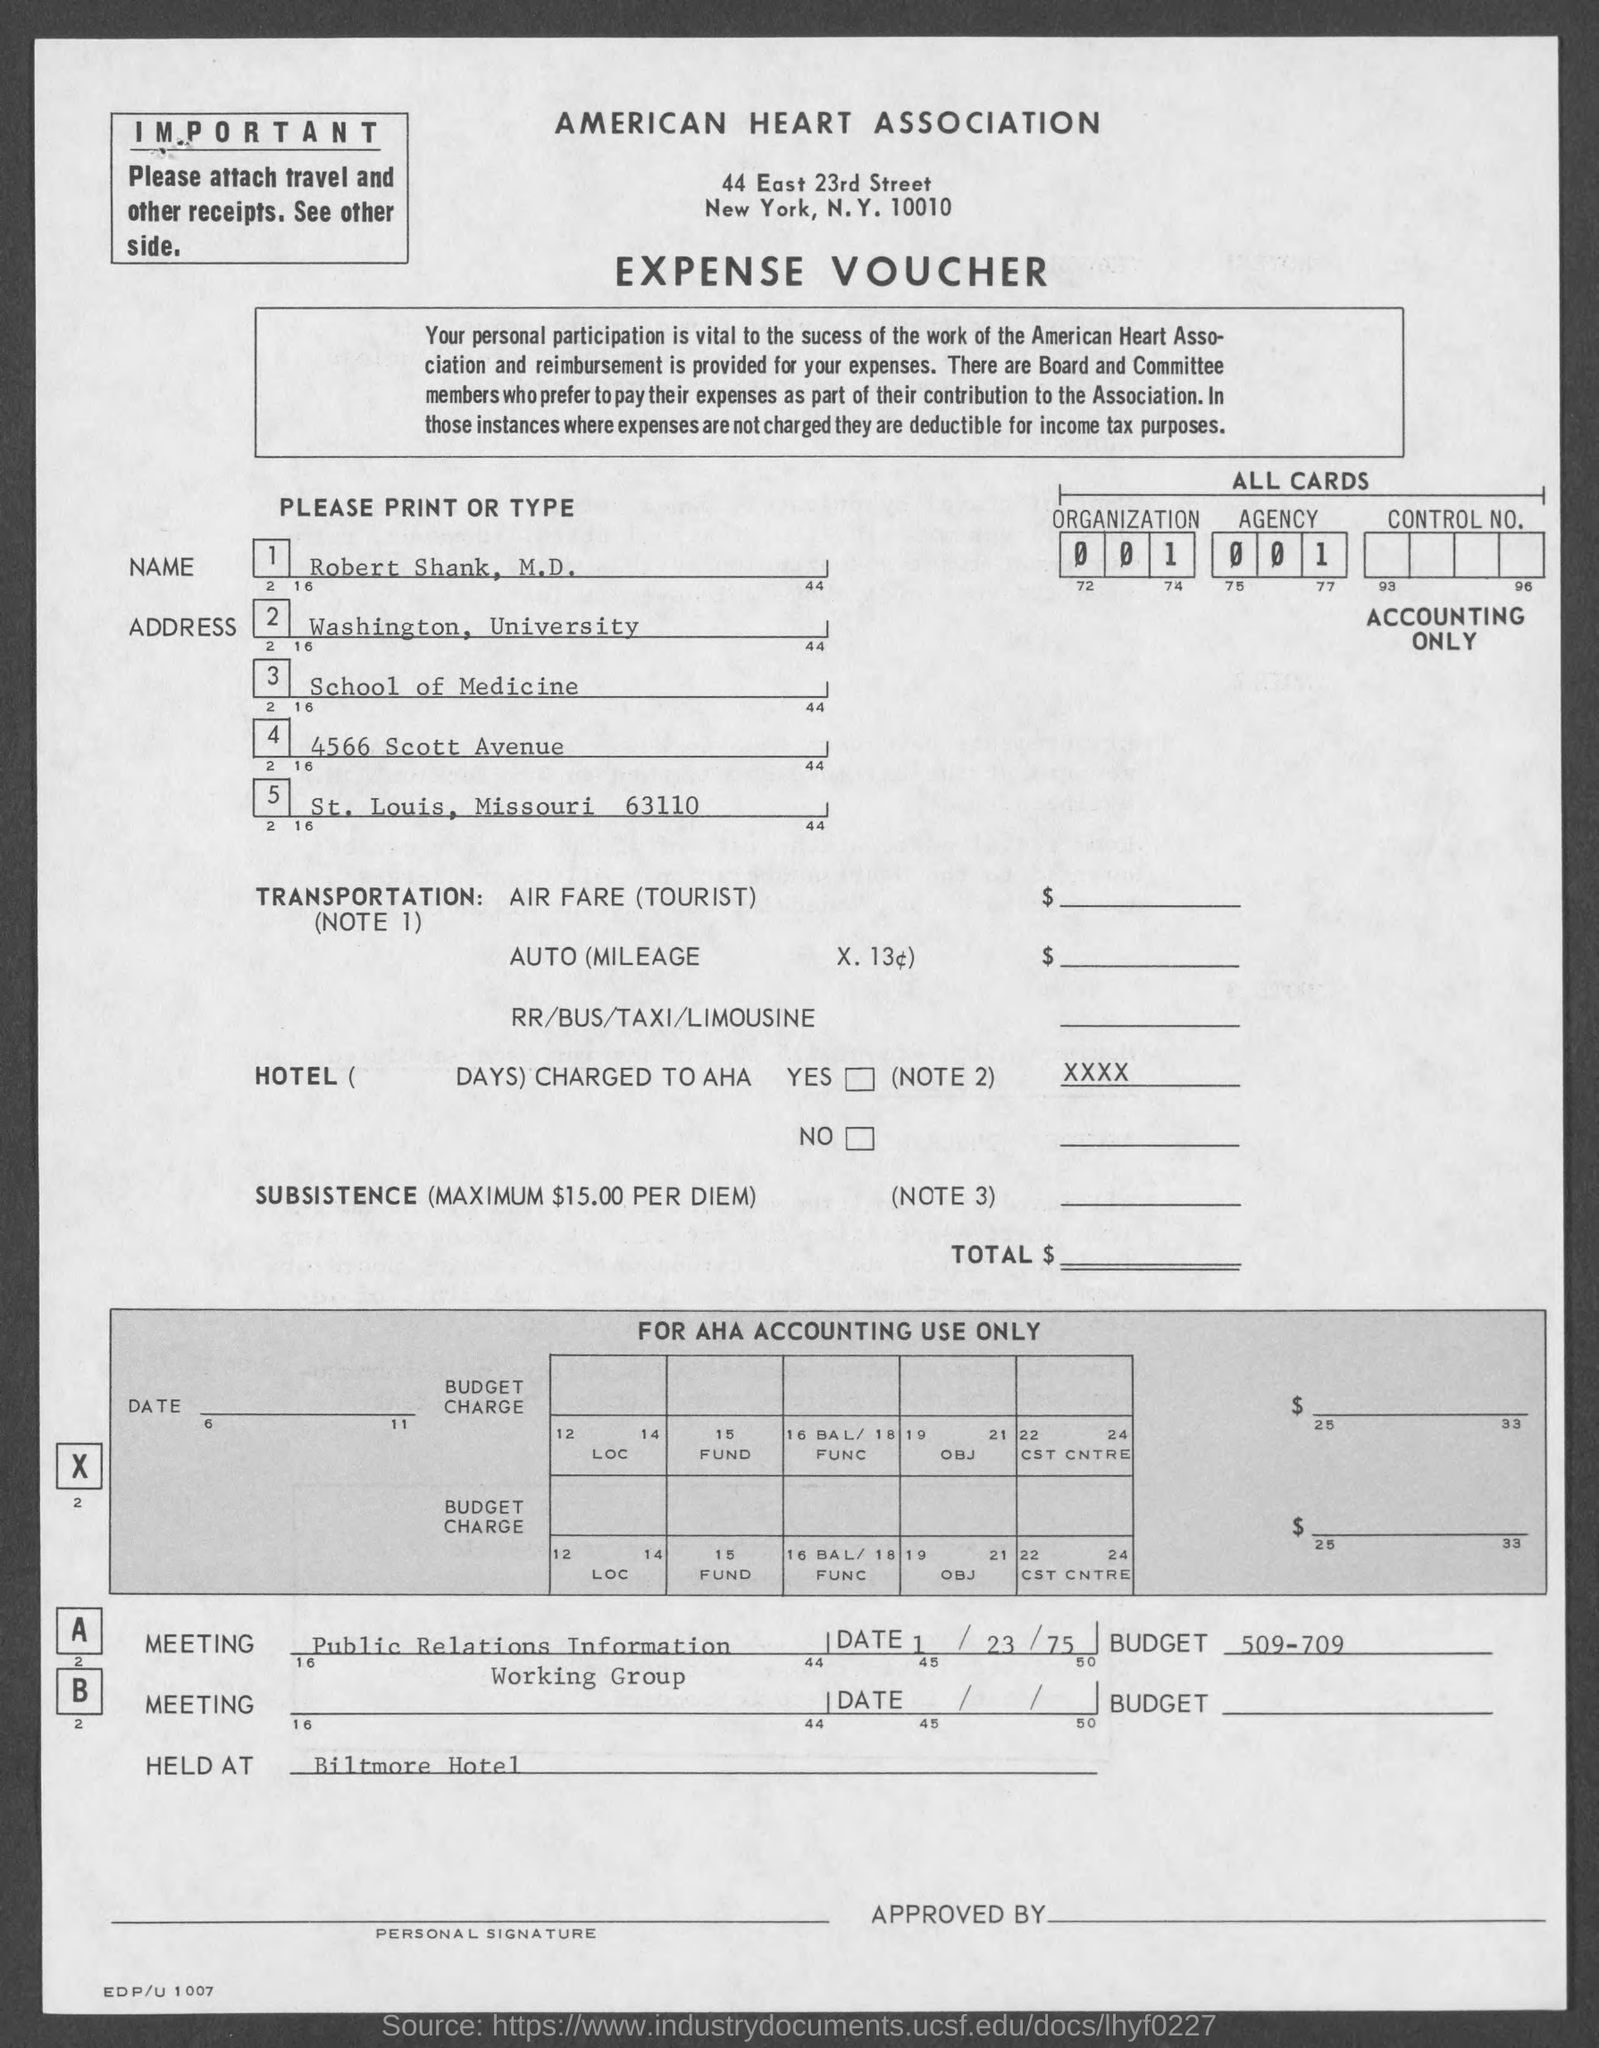What kind of voucher is this?
Offer a very short reply. Expense voucher. This voucher belongs to which association?
Your answer should be very brief. American heart association. What is the name of the person?
Give a very brief answer. Robert shank, m.d. Robert Shank is in which state?
Your answer should be compact. Missouri. Where was the meeting held?
Make the answer very short. Biltmore hotel. On which day was the meeting A held?
Make the answer very short. 1/23/75. What was the budget of meeting A?
Keep it short and to the point. 509-709. 